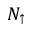<formula> <loc_0><loc_0><loc_500><loc_500>N _ { \uparrow }</formula> 